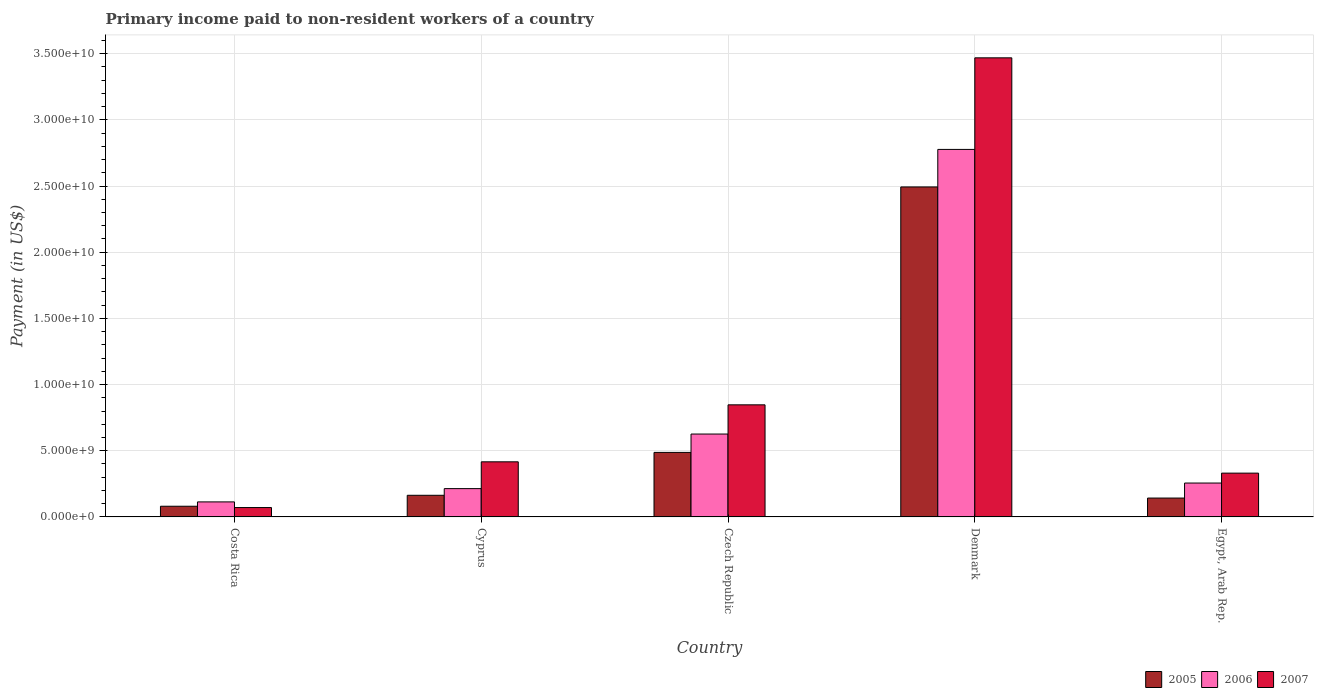How many groups of bars are there?
Provide a succinct answer. 5. Are the number of bars per tick equal to the number of legend labels?
Ensure brevity in your answer.  Yes. How many bars are there on the 4th tick from the right?
Ensure brevity in your answer.  3. What is the label of the 5th group of bars from the left?
Give a very brief answer. Egypt, Arab Rep. In how many cases, is the number of bars for a given country not equal to the number of legend labels?
Offer a very short reply. 0. What is the amount paid to workers in 2007 in Egypt, Arab Rep.?
Keep it short and to the point. 3.31e+09. Across all countries, what is the maximum amount paid to workers in 2005?
Your answer should be very brief. 2.49e+1. Across all countries, what is the minimum amount paid to workers in 2006?
Make the answer very short. 1.14e+09. In which country was the amount paid to workers in 2006 maximum?
Keep it short and to the point. Denmark. In which country was the amount paid to workers in 2005 minimum?
Offer a terse response. Costa Rica. What is the total amount paid to workers in 2005 in the graph?
Your response must be concise. 3.37e+1. What is the difference between the amount paid to workers in 2006 in Cyprus and that in Denmark?
Make the answer very short. -2.56e+1. What is the difference between the amount paid to workers in 2005 in Denmark and the amount paid to workers in 2006 in Egypt, Arab Rep.?
Offer a very short reply. 2.24e+1. What is the average amount paid to workers in 2006 per country?
Ensure brevity in your answer.  7.97e+09. What is the difference between the amount paid to workers of/in 2005 and amount paid to workers of/in 2007 in Czech Republic?
Keep it short and to the point. -3.59e+09. In how many countries, is the amount paid to workers in 2005 greater than 18000000000 US$?
Give a very brief answer. 1. What is the ratio of the amount paid to workers in 2007 in Czech Republic to that in Denmark?
Offer a very short reply. 0.24. Is the amount paid to workers in 2006 in Czech Republic less than that in Denmark?
Your answer should be compact. Yes. What is the difference between the highest and the second highest amount paid to workers in 2006?
Give a very brief answer. -2.52e+1. What is the difference between the highest and the lowest amount paid to workers in 2007?
Make the answer very short. 3.40e+1. What does the 2nd bar from the left in Egypt, Arab Rep. represents?
Your answer should be compact. 2006. What does the 1st bar from the right in Denmark represents?
Offer a terse response. 2007. Is it the case that in every country, the sum of the amount paid to workers in 2005 and amount paid to workers in 2006 is greater than the amount paid to workers in 2007?
Keep it short and to the point. No. How many bars are there?
Give a very brief answer. 15. How many countries are there in the graph?
Your answer should be compact. 5. Does the graph contain grids?
Offer a very short reply. Yes. Where does the legend appear in the graph?
Give a very brief answer. Bottom right. What is the title of the graph?
Provide a succinct answer. Primary income paid to non-resident workers of a country. What is the label or title of the Y-axis?
Offer a very short reply. Payment (in US$). What is the Payment (in US$) of 2005 in Costa Rica?
Keep it short and to the point. 8.07e+08. What is the Payment (in US$) in 2006 in Costa Rica?
Keep it short and to the point. 1.14e+09. What is the Payment (in US$) in 2007 in Costa Rica?
Your answer should be compact. 7.08e+08. What is the Payment (in US$) of 2005 in Cyprus?
Give a very brief answer. 1.63e+09. What is the Payment (in US$) of 2006 in Cyprus?
Offer a very short reply. 2.14e+09. What is the Payment (in US$) of 2007 in Cyprus?
Give a very brief answer. 4.16e+09. What is the Payment (in US$) in 2005 in Czech Republic?
Your answer should be very brief. 4.87e+09. What is the Payment (in US$) in 2006 in Czech Republic?
Ensure brevity in your answer.  6.26e+09. What is the Payment (in US$) of 2007 in Czech Republic?
Provide a succinct answer. 8.47e+09. What is the Payment (in US$) of 2005 in Denmark?
Your answer should be compact. 2.49e+1. What is the Payment (in US$) in 2006 in Denmark?
Offer a terse response. 2.78e+1. What is the Payment (in US$) in 2007 in Denmark?
Make the answer very short. 3.47e+1. What is the Payment (in US$) of 2005 in Egypt, Arab Rep.?
Ensure brevity in your answer.  1.43e+09. What is the Payment (in US$) in 2006 in Egypt, Arab Rep.?
Provide a short and direct response. 2.56e+09. What is the Payment (in US$) in 2007 in Egypt, Arab Rep.?
Your response must be concise. 3.31e+09. Across all countries, what is the maximum Payment (in US$) of 2005?
Ensure brevity in your answer.  2.49e+1. Across all countries, what is the maximum Payment (in US$) in 2006?
Offer a terse response. 2.78e+1. Across all countries, what is the maximum Payment (in US$) of 2007?
Your answer should be compact. 3.47e+1. Across all countries, what is the minimum Payment (in US$) of 2005?
Ensure brevity in your answer.  8.07e+08. Across all countries, what is the minimum Payment (in US$) of 2006?
Keep it short and to the point. 1.14e+09. Across all countries, what is the minimum Payment (in US$) in 2007?
Offer a very short reply. 7.08e+08. What is the total Payment (in US$) in 2005 in the graph?
Provide a short and direct response. 3.37e+1. What is the total Payment (in US$) of 2006 in the graph?
Provide a succinct answer. 3.99e+1. What is the total Payment (in US$) in 2007 in the graph?
Keep it short and to the point. 5.13e+1. What is the difference between the Payment (in US$) of 2005 in Costa Rica and that in Cyprus?
Provide a succinct answer. -8.28e+08. What is the difference between the Payment (in US$) in 2006 in Costa Rica and that in Cyprus?
Offer a very short reply. -1.00e+09. What is the difference between the Payment (in US$) of 2007 in Costa Rica and that in Cyprus?
Give a very brief answer. -3.46e+09. What is the difference between the Payment (in US$) in 2005 in Costa Rica and that in Czech Republic?
Your response must be concise. -4.07e+09. What is the difference between the Payment (in US$) of 2006 in Costa Rica and that in Czech Republic?
Your answer should be very brief. -5.13e+09. What is the difference between the Payment (in US$) of 2007 in Costa Rica and that in Czech Republic?
Your response must be concise. -7.76e+09. What is the difference between the Payment (in US$) of 2005 in Costa Rica and that in Denmark?
Your answer should be very brief. -2.41e+1. What is the difference between the Payment (in US$) of 2006 in Costa Rica and that in Denmark?
Ensure brevity in your answer.  -2.66e+1. What is the difference between the Payment (in US$) of 2007 in Costa Rica and that in Denmark?
Offer a very short reply. -3.40e+1. What is the difference between the Payment (in US$) in 2005 in Costa Rica and that in Egypt, Arab Rep.?
Keep it short and to the point. -6.19e+08. What is the difference between the Payment (in US$) in 2006 in Costa Rica and that in Egypt, Arab Rep.?
Make the answer very short. -1.43e+09. What is the difference between the Payment (in US$) in 2007 in Costa Rica and that in Egypt, Arab Rep.?
Ensure brevity in your answer.  -2.60e+09. What is the difference between the Payment (in US$) in 2005 in Cyprus and that in Czech Republic?
Keep it short and to the point. -3.24e+09. What is the difference between the Payment (in US$) in 2006 in Cyprus and that in Czech Republic?
Your answer should be compact. -4.12e+09. What is the difference between the Payment (in US$) of 2007 in Cyprus and that in Czech Republic?
Provide a short and direct response. -4.30e+09. What is the difference between the Payment (in US$) of 2005 in Cyprus and that in Denmark?
Your response must be concise. -2.33e+1. What is the difference between the Payment (in US$) of 2006 in Cyprus and that in Denmark?
Provide a short and direct response. -2.56e+1. What is the difference between the Payment (in US$) of 2007 in Cyprus and that in Denmark?
Provide a short and direct response. -3.05e+1. What is the difference between the Payment (in US$) in 2005 in Cyprus and that in Egypt, Arab Rep.?
Provide a succinct answer. 2.09e+08. What is the difference between the Payment (in US$) of 2006 in Cyprus and that in Egypt, Arab Rep.?
Make the answer very short. -4.21e+08. What is the difference between the Payment (in US$) in 2007 in Cyprus and that in Egypt, Arab Rep.?
Offer a very short reply. 8.54e+08. What is the difference between the Payment (in US$) in 2005 in Czech Republic and that in Denmark?
Ensure brevity in your answer.  -2.01e+1. What is the difference between the Payment (in US$) of 2006 in Czech Republic and that in Denmark?
Offer a very short reply. -2.15e+1. What is the difference between the Payment (in US$) of 2007 in Czech Republic and that in Denmark?
Offer a terse response. -2.62e+1. What is the difference between the Payment (in US$) of 2005 in Czech Republic and that in Egypt, Arab Rep.?
Your answer should be very brief. 3.45e+09. What is the difference between the Payment (in US$) in 2006 in Czech Republic and that in Egypt, Arab Rep.?
Ensure brevity in your answer.  3.70e+09. What is the difference between the Payment (in US$) of 2007 in Czech Republic and that in Egypt, Arab Rep.?
Provide a succinct answer. 5.16e+09. What is the difference between the Payment (in US$) in 2005 in Denmark and that in Egypt, Arab Rep.?
Give a very brief answer. 2.35e+1. What is the difference between the Payment (in US$) of 2006 in Denmark and that in Egypt, Arab Rep.?
Your response must be concise. 2.52e+1. What is the difference between the Payment (in US$) in 2007 in Denmark and that in Egypt, Arab Rep.?
Ensure brevity in your answer.  3.14e+1. What is the difference between the Payment (in US$) in 2005 in Costa Rica and the Payment (in US$) in 2006 in Cyprus?
Your response must be concise. -1.33e+09. What is the difference between the Payment (in US$) in 2005 in Costa Rica and the Payment (in US$) in 2007 in Cyprus?
Keep it short and to the point. -3.36e+09. What is the difference between the Payment (in US$) in 2006 in Costa Rica and the Payment (in US$) in 2007 in Cyprus?
Give a very brief answer. -3.03e+09. What is the difference between the Payment (in US$) of 2005 in Costa Rica and the Payment (in US$) of 2006 in Czech Republic?
Offer a very short reply. -5.46e+09. What is the difference between the Payment (in US$) of 2005 in Costa Rica and the Payment (in US$) of 2007 in Czech Republic?
Offer a very short reply. -7.66e+09. What is the difference between the Payment (in US$) in 2006 in Costa Rica and the Payment (in US$) in 2007 in Czech Republic?
Provide a short and direct response. -7.33e+09. What is the difference between the Payment (in US$) of 2005 in Costa Rica and the Payment (in US$) of 2006 in Denmark?
Provide a succinct answer. -2.70e+1. What is the difference between the Payment (in US$) in 2005 in Costa Rica and the Payment (in US$) in 2007 in Denmark?
Ensure brevity in your answer.  -3.39e+1. What is the difference between the Payment (in US$) in 2006 in Costa Rica and the Payment (in US$) in 2007 in Denmark?
Ensure brevity in your answer.  -3.35e+1. What is the difference between the Payment (in US$) of 2005 in Costa Rica and the Payment (in US$) of 2006 in Egypt, Arab Rep.?
Provide a short and direct response. -1.75e+09. What is the difference between the Payment (in US$) in 2005 in Costa Rica and the Payment (in US$) in 2007 in Egypt, Arab Rep.?
Offer a very short reply. -2.50e+09. What is the difference between the Payment (in US$) of 2006 in Costa Rica and the Payment (in US$) of 2007 in Egypt, Arab Rep.?
Make the answer very short. -2.17e+09. What is the difference between the Payment (in US$) of 2005 in Cyprus and the Payment (in US$) of 2006 in Czech Republic?
Ensure brevity in your answer.  -4.63e+09. What is the difference between the Payment (in US$) of 2005 in Cyprus and the Payment (in US$) of 2007 in Czech Republic?
Give a very brief answer. -6.83e+09. What is the difference between the Payment (in US$) of 2006 in Cyprus and the Payment (in US$) of 2007 in Czech Republic?
Provide a succinct answer. -6.33e+09. What is the difference between the Payment (in US$) in 2005 in Cyprus and the Payment (in US$) in 2006 in Denmark?
Provide a short and direct response. -2.61e+1. What is the difference between the Payment (in US$) in 2005 in Cyprus and the Payment (in US$) in 2007 in Denmark?
Give a very brief answer. -3.30e+1. What is the difference between the Payment (in US$) of 2006 in Cyprus and the Payment (in US$) of 2007 in Denmark?
Your response must be concise. -3.25e+1. What is the difference between the Payment (in US$) of 2005 in Cyprus and the Payment (in US$) of 2006 in Egypt, Arab Rep.?
Provide a short and direct response. -9.26e+08. What is the difference between the Payment (in US$) of 2005 in Cyprus and the Payment (in US$) of 2007 in Egypt, Arab Rep.?
Ensure brevity in your answer.  -1.67e+09. What is the difference between the Payment (in US$) in 2006 in Cyprus and the Payment (in US$) in 2007 in Egypt, Arab Rep.?
Keep it short and to the point. -1.17e+09. What is the difference between the Payment (in US$) of 2005 in Czech Republic and the Payment (in US$) of 2006 in Denmark?
Provide a succinct answer. -2.29e+1. What is the difference between the Payment (in US$) in 2005 in Czech Republic and the Payment (in US$) in 2007 in Denmark?
Provide a succinct answer. -2.98e+1. What is the difference between the Payment (in US$) of 2006 in Czech Republic and the Payment (in US$) of 2007 in Denmark?
Offer a terse response. -2.84e+1. What is the difference between the Payment (in US$) of 2005 in Czech Republic and the Payment (in US$) of 2006 in Egypt, Arab Rep.?
Offer a terse response. 2.31e+09. What is the difference between the Payment (in US$) of 2005 in Czech Republic and the Payment (in US$) of 2007 in Egypt, Arab Rep.?
Ensure brevity in your answer.  1.57e+09. What is the difference between the Payment (in US$) of 2006 in Czech Republic and the Payment (in US$) of 2007 in Egypt, Arab Rep.?
Provide a succinct answer. 2.95e+09. What is the difference between the Payment (in US$) of 2005 in Denmark and the Payment (in US$) of 2006 in Egypt, Arab Rep.?
Your response must be concise. 2.24e+1. What is the difference between the Payment (in US$) of 2005 in Denmark and the Payment (in US$) of 2007 in Egypt, Arab Rep.?
Your response must be concise. 2.16e+1. What is the difference between the Payment (in US$) in 2006 in Denmark and the Payment (in US$) in 2007 in Egypt, Arab Rep.?
Your response must be concise. 2.45e+1. What is the average Payment (in US$) of 2005 per country?
Provide a succinct answer. 6.73e+09. What is the average Payment (in US$) of 2006 per country?
Offer a very short reply. 7.97e+09. What is the average Payment (in US$) of 2007 per country?
Your response must be concise. 1.03e+1. What is the difference between the Payment (in US$) in 2005 and Payment (in US$) in 2006 in Costa Rica?
Ensure brevity in your answer.  -3.28e+08. What is the difference between the Payment (in US$) of 2005 and Payment (in US$) of 2007 in Costa Rica?
Give a very brief answer. 9.92e+07. What is the difference between the Payment (in US$) of 2006 and Payment (in US$) of 2007 in Costa Rica?
Offer a very short reply. 4.27e+08. What is the difference between the Payment (in US$) of 2005 and Payment (in US$) of 2006 in Cyprus?
Your response must be concise. -5.04e+08. What is the difference between the Payment (in US$) of 2005 and Payment (in US$) of 2007 in Cyprus?
Make the answer very short. -2.53e+09. What is the difference between the Payment (in US$) of 2006 and Payment (in US$) of 2007 in Cyprus?
Keep it short and to the point. -2.02e+09. What is the difference between the Payment (in US$) of 2005 and Payment (in US$) of 2006 in Czech Republic?
Provide a succinct answer. -1.39e+09. What is the difference between the Payment (in US$) in 2005 and Payment (in US$) in 2007 in Czech Republic?
Your response must be concise. -3.59e+09. What is the difference between the Payment (in US$) in 2006 and Payment (in US$) in 2007 in Czech Republic?
Keep it short and to the point. -2.21e+09. What is the difference between the Payment (in US$) of 2005 and Payment (in US$) of 2006 in Denmark?
Your answer should be compact. -2.84e+09. What is the difference between the Payment (in US$) of 2005 and Payment (in US$) of 2007 in Denmark?
Keep it short and to the point. -9.75e+09. What is the difference between the Payment (in US$) of 2006 and Payment (in US$) of 2007 in Denmark?
Make the answer very short. -6.92e+09. What is the difference between the Payment (in US$) of 2005 and Payment (in US$) of 2006 in Egypt, Arab Rep.?
Your response must be concise. -1.14e+09. What is the difference between the Payment (in US$) of 2005 and Payment (in US$) of 2007 in Egypt, Arab Rep.?
Keep it short and to the point. -1.88e+09. What is the difference between the Payment (in US$) of 2006 and Payment (in US$) of 2007 in Egypt, Arab Rep.?
Keep it short and to the point. -7.49e+08. What is the ratio of the Payment (in US$) in 2005 in Costa Rica to that in Cyprus?
Make the answer very short. 0.49. What is the ratio of the Payment (in US$) of 2006 in Costa Rica to that in Cyprus?
Give a very brief answer. 0.53. What is the ratio of the Payment (in US$) of 2007 in Costa Rica to that in Cyprus?
Provide a short and direct response. 0.17. What is the ratio of the Payment (in US$) in 2005 in Costa Rica to that in Czech Republic?
Your answer should be very brief. 0.17. What is the ratio of the Payment (in US$) in 2006 in Costa Rica to that in Czech Republic?
Your answer should be very brief. 0.18. What is the ratio of the Payment (in US$) in 2007 in Costa Rica to that in Czech Republic?
Keep it short and to the point. 0.08. What is the ratio of the Payment (in US$) in 2005 in Costa Rica to that in Denmark?
Your answer should be compact. 0.03. What is the ratio of the Payment (in US$) in 2006 in Costa Rica to that in Denmark?
Provide a succinct answer. 0.04. What is the ratio of the Payment (in US$) in 2007 in Costa Rica to that in Denmark?
Your answer should be compact. 0.02. What is the ratio of the Payment (in US$) of 2005 in Costa Rica to that in Egypt, Arab Rep.?
Offer a very short reply. 0.57. What is the ratio of the Payment (in US$) of 2006 in Costa Rica to that in Egypt, Arab Rep.?
Your answer should be very brief. 0.44. What is the ratio of the Payment (in US$) of 2007 in Costa Rica to that in Egypt, Arab Rep.?
Your answer should be very brief. 0.21. What is the ratio of the Payment (in US$) in 2005 in Cyprus to that in Czech Republic?
Offer a very short reply. 0.34. What is the ratio of the Payment (in US$) in 2006 in Cyprus to that in Czech Republic?
Keep it short and to the point. 0.34. What is the ratio of the Payment (in US$) in 2007 in Cyprus to that in Czech Republic?
Keep it short and to the point. 0.49. What is the ratio of the Payment (in US$) of 2005 in Cyprus to that in Denmark?
Offer a terse response. 0.07. What is the ratio of the Payment (in US$) in 2006 in Cyprus to that in Denmark?
Your response must be concise. 0.08. What is the ratio of the Payment (in US$) of 2007 in Cyprus to that in Denmark?
Your response must be concise. 0.12. What is the ratio of the Payment (in US$) of 2005 in Cyprus to that in Egypt, Arab Rep.?
Keep it short and to the point. 1.15. What is the ratio of the Payment (in US$) in 2006 in Cyprus to that in Egypt, Arab Rep.?
Offer a terse response. 0.84. What is the ratio of the Payment (in US$) of 2007 in Cyprus to that in Egypt, Arab Rep.?
Offer a very short reply. 1.26. What is the ratio of the Payment (in US$) in 2005 in Czech Republic to that in Denmark?
Provide a succinct answer. 0.2. What is the ratio of the Payment (in US$) in 2006 in Czech Republic to that in Denmark?
Ensure brevity in your answer.  0.23. What is the ratio of the Payment (in US$) in 2007 in Czech Republic to that in Denmark?
Keep it short and to the point. 0.24. What is the ratio of the Payment (in US$) of 2005 in Czech Republic to that in Egypt, Arab Rep.?
Make the answer very short. 3.42. What is the ratio of the Payment (in US$) in 2006 in Czech Republic to that in Egypt, Arab Rep.?
Offer a terse response. 2.45. What is the ratio of the Payment (in US$) of 2007 in Czech Republic to that in Egypt, Arab Rep.?
Make the answer very short. 2.56. What is the ratio of the Payment (in US$) in 2005 in Denmark to that in Egypt, Arab Rep.?
Provide a succinct answer. 17.49. What is the ratio of the Payment (in US$) in 2006 in Denmark to that in Egypt, Arab Rep.?
Your answer should be very brief. 10.84. What is the ratio of the Payment (in US$) in 2007 in Denmark to that in Egypt, Arab Rep.?
Offer a terse response. 10.48. What is the difference between the highest and the second highest Payment (in US$) in 2005?
Your response must be concise. 2.01e+1. What is the difference between the highest and the second highest Payment (in US$) in 2006?
Your answer should be compact. 2.15e+1. What is the difference between the highest and the second highest Payment (in US$) of 2007?
Give a very brief answer. 2.62e+1. What is the difference between the highest and the lowest Payment (in US$) of 2005?
Offer a very short reply. 2.41e+1. What is the difference between the highest and the lowest Payment (in US$) of 2006?
Your answer should be very brief. 2.66e+1. What is the difference between the highest and the lowest Payment (in US$) of 2007?
Provide a short and direct response. 3.40e+1. 